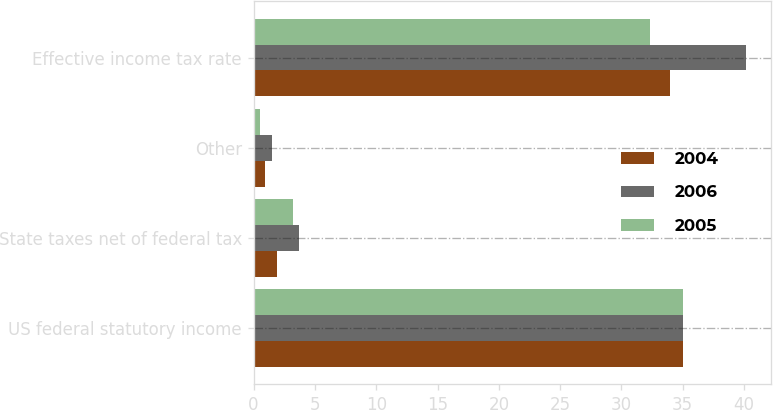Convert chart. <chart><loc_0><loc_0><loc_500><loc_500><stacked_bar_chart><ecel><fcel>US federal statutory income<fcel>State taxes net of federal tax<fcel>Other<fcel>Effective income tax rate<nl><fcel>2004<fcel>35<fcel>1.9<fcel>0.9<fcel>34<nl><fcel>2006<fcel>35<fcel>3.7<fcel>1.5<fcel>40.2<nl><fcel>2005<fcel>35<fcel>3.2<fcel>0.5<fcel>32.3<nl></chart> 